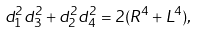<formula> <loc_0><loc_0><loc_500><loc_500>d _ { 1 } ^ { 2 } d _ { 3 } ^ { 2 } + d _ { 2 } ^ { 2 } d _ { 4 } ^ { 2 } = 2 ( R ^ { 4 } + L ^ { 4 } ) ,</formula> 